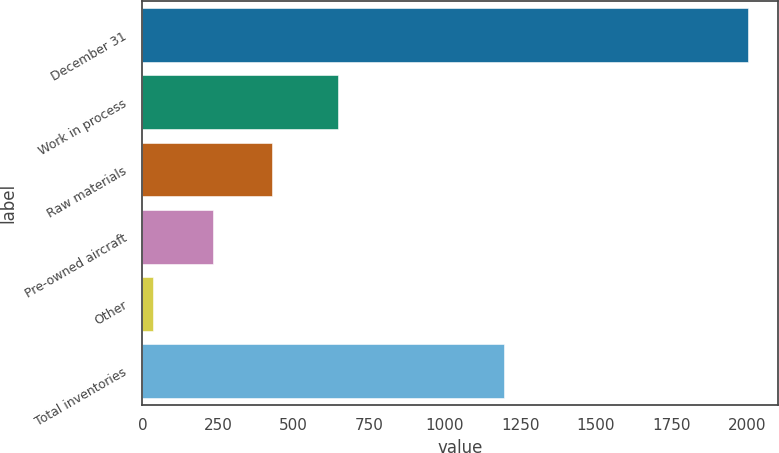Convert chart to OTSL. <chart><loc_0><loc_0><loc_500><loc_500><bar_chart><fcel>December 31<fcel>Work in process<fcel>Raw materials<fcel>Pre-owned aircraft<fcel>Other<fcel>Total inventories<nl><fcel>2004<fcel>648<fcel>429.6<fcel>232.8<fcel>36<fcel>1195<nl></chart> 